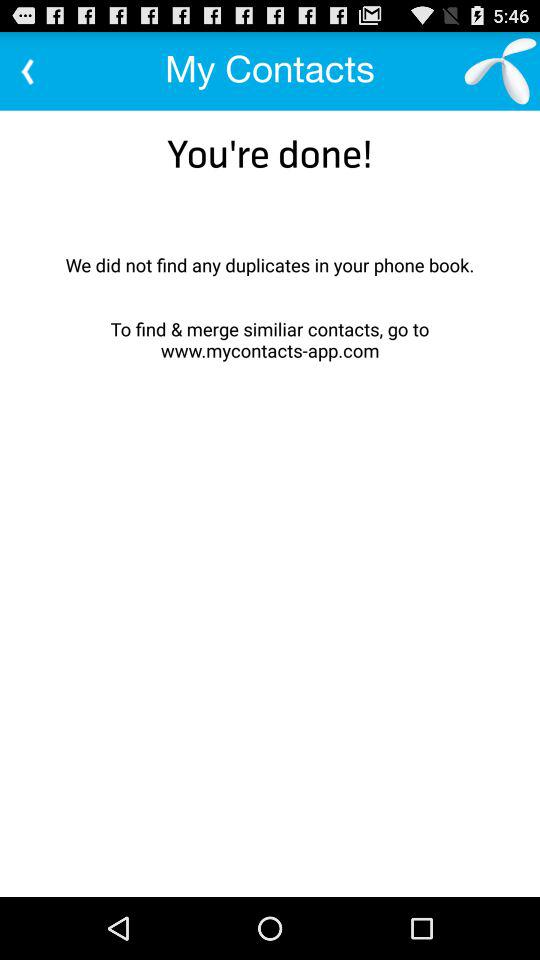How many duplicates were found in the phone book?
Answer the question using a single word or phrase. 0 